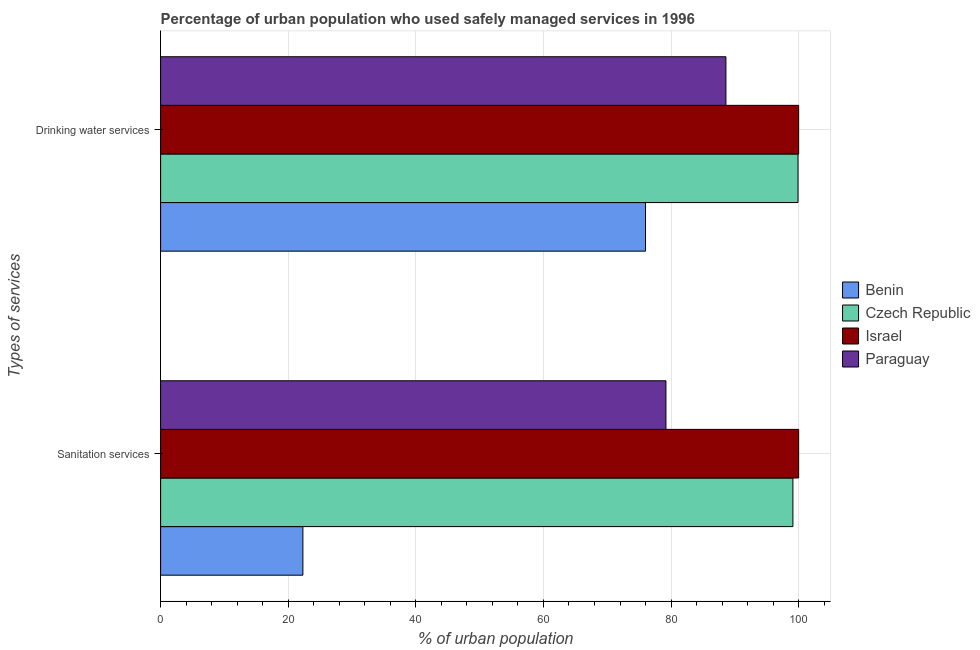How many different coloured bars are there?
Give a very brief answer. 4. Are the number of bars on each tick of the Y-axis equal?
Your answer should be compact. Yes. What is the label of the 1st group of bars from the top?
Your answer should be very brief. Drinking water services. What is the percentage of urban population who used drinking water services in Czech Republic?
Your answer should be compact. 99.9. Across all countries, what is the minimum percentage of urban population who used sanitation services?
Your answer should be compact. 22.3. In which country was the percentage of urban population who used sanitation services maximum?
Keep it short and to the point. Israel. In which country was the percentage of urban population who used sanitation services minimum?
Provide a short and direct response. Benin. What is the total percentage of urban population who used sanitation services in the graph?
Provide a short and direct response. 300.6. What is the difference between the percentage of urban population who used sanitation services in Paraguay and that in Israel?
Offer a terse response. -20.8. What is the difference between the percentage of urban population who used sanitation services in Benin and the percentage of urban population who used drinking water services in Czech Republic?
Give a very brief answer. -77.6. What is the average percentage of urban population who used sanitation services per country?
Offer a terse response. 75.15. What is the difference between the percentage of urban population who used drinking water services and percentage of urban population who used sanitation services in Israel?
Provide a short and direct response. 0. In how many countries, is the percentage of urban population who used drinking water services greater than 32 %?
Give a very brief answer. 4. What is the ratio of the percentage of urban population who used sanitation services in Benin to that in Paraguay?
Keep it short and to the point. 0.28. What does the 1st bar from the top in Sanitation services represents?
Ensure brevity in your answer.  Paraguay. What does the 4th bar from the bottom in Drinking water services represents?
Your response must be concise. Paraguay. How many bars are there?
Offer a terse response. 8. What is the difference between two consecutive major ticks on the X-axis?
Offer a terse response. 20. Does the graph contain any zero values?
Provide a short and direct response. No. How many legend labels are there?
Give a very brief answer. 4. What is the title of the graph?
Ensure brevity in your answer.  Percentage of urban population who used safely managed services in 1996. What is the label or title of the X-axis?
Offer a terse response. % of urban population. What is the label or title of the Y-axis?
Your response must be concise. Types of services. What is the % of urban population of Benin in Sanitation services?
Give a very brief answer. 22.3. What is the % of urban population of Czech Republic in Sanitation services?
Offer a very short reply. 99.1. What is the % of urban population of Israel in Sanitation services?
Offer a terse response. 100. What is the % of urban population of Paraguay in Sanitation services?
Provide a short and direct response. 79.2. What is the % of urban population of Czech Republic in Drinking water services?
Your answer should be very brief. 99.9. What is the % of urban population in Paraguay in Drinking water services?
Provide a short and direct response. 88.6. Across all Types of services, what is the maximum % of urban population of Czech Republic?
Your answer should be compact. 99.9. Across all Types of services, what is the maximum % of urban population in Israel?
Keep it short and to the point. 100. Across all Types of services, what is the maximum % of urban population of Paraguay?
Make the answer very short. 88.6. Across all Types of services, what is the minimum % of urban population of Benin?
Offer a very short reply. 22.3. Across all Types of services, what is the minimum % of urban population of Czech Republic?
Offer a very short reply. 99.1. Across all Types of services, what is the minimum % of urban population in Israel?
Your answer should be compact. 100. Across all Types of services, what is the minimum % of urban population of Paraguay?
Provide a succinct answer. 79.2. What is the total % of urban population in Benin in the graph?
Provide a succinct answer. 98.3. What is the total % of urban population of Czech Republic in the graph?
Provide a succinct answer. 199. What is the total % of urban population of Israel in the graph?
Your answer should be compact. 200. What is the total % of urban population of Paraguay in the graph?
Offer a very short reply. 167.8. What is the difference between the % of urban population in Benin in Sanitation services and that in Drinking water services?
Your answer should be very brief. -53.7. What is the difference between the % of urban population in Israel in Sanitation services and that in Drinking water services?
Make the answer very short. 0. What is the difference between the % of urban population of Benin in Sanitation services and the % of urban population of Czech Republic in Drinking water services?
Offer a very short reply. -77.6. What is the difference between the % of urban population in Benin in Sanitation services and the % of urban population in Israel in Drinking water services?
Keep it short and to the point. -77.7. What is the difference between the % of urban population in Benin in Sanitation services and the % of urban population in Paraguay in Drinking water services?
Provide a short and direct response. -66.3. What is the difference between the % of urban population of Czech Republic in Sanitation services and the % of urban population of Israel in Drinking water services?
Provide a short and direct response. -0.9. What is the difference between the % of urban population in Czech Republic in Sanitation services and the % of urban population in Paraguay in Drinking water services?
Your answer should be compact. 10.5. What is the average % of urban population in Benin per Types of services?
Keep it short and to the point. 49.15. What is the average % of urban population of Czech Republic per Types of services?
Keep it short and to the point. 99.5. What is the average % of urban population in Paraguay per Types of services?
Provide a short and direct response. 83.9. What is the difference between the % of urban population of Benin and % of urban population of Czech Republic in Sanitation services?
Provide a succinct answer. -76.8. What is the difference between the % of urban population of Benin and % of urban population of Israel in Sanitation services?
Make the answer very short. -77.7. What is the difference between the % of urban population in Benin and % of urban population in Paraguay in Sanitation services?
Keep it short and to the point. -56.9. What is the difference between the % of urban population of Israel and % of urban population of Paraguay in Sanitation services?
Ensure brevity in your answer.  20.8. What is the difference between the % of urban population of Benin and % of urban population of Czech Republic in Drinking water services?
Your response must be concise. -23.9. What is the ratio of the % of urban population in Benin in Sanitation services to that in Drinking water services?
Offer a terse response. 0.29. What is the ratio of the % of urban population in Czech Republic in Sanitation services to that in Drinking water services?
Your answer should be very brief. 0.99. What is the ratio of the % of urban population in Paraguay in Sanitation services to that in Drinking water services?
Offer a terse response. 0.89. What is the difference between the highest and the second highest % of urban population of Benin?
Your answer should be very brief. 53.7. What is the difference between the highest and the second highest % of urban population in Israel?
Make the answer very short. 0. What is the difference between the highest and the lowest % of urban population of Benin?
Keep it short and to the point. 53.7. What is the difference between the highest and the lowest % of urban population of Israel?
Offer a terse response. 0. 